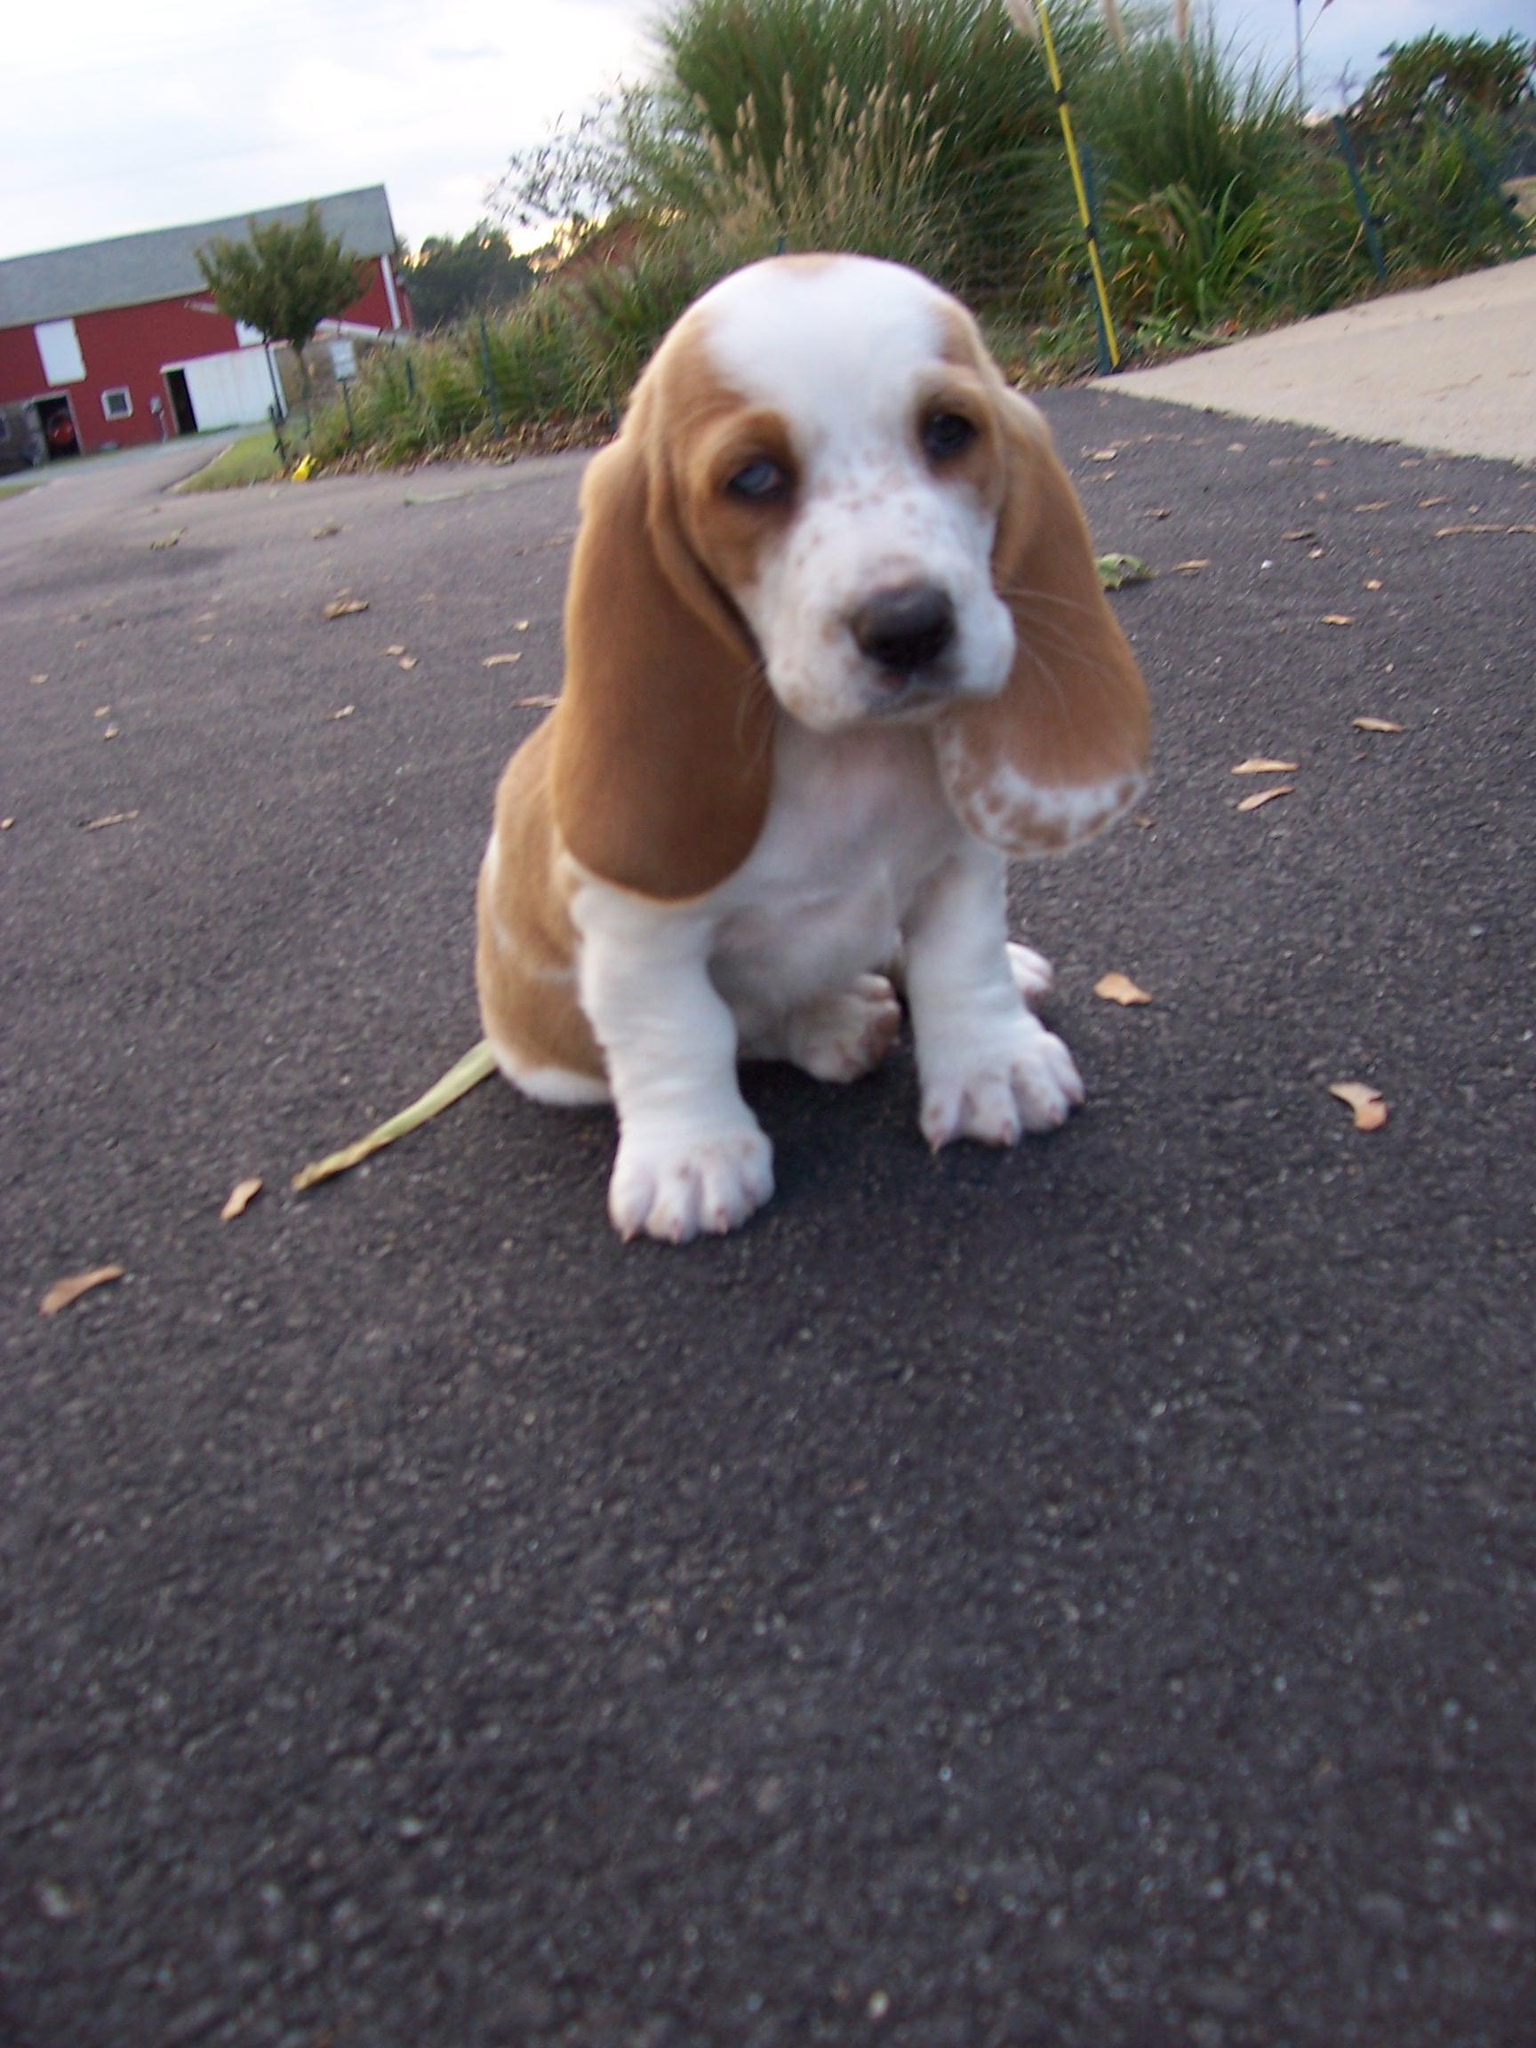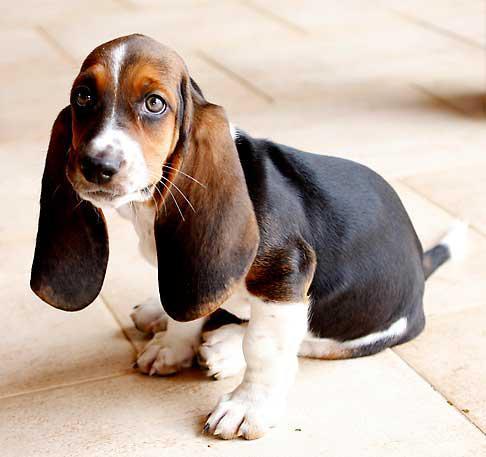The first image is the image on the left, the second image is the image on the right. Analyze the images presented: Is the assertion "At least one of the dogs is outside." valid? Answer yes or no. Yes. The first image is the image on the left, the second image is the image on the right. For the images shown, is this caption "Both dogs are sitting down." true? Answer yes or no. Yes. The first image is the image on the left, the second image is the image on the right. For the images shown, is this caption "There is green vegetation visible in the background of at least one of the images." true? Answer yes or no. Yes. 